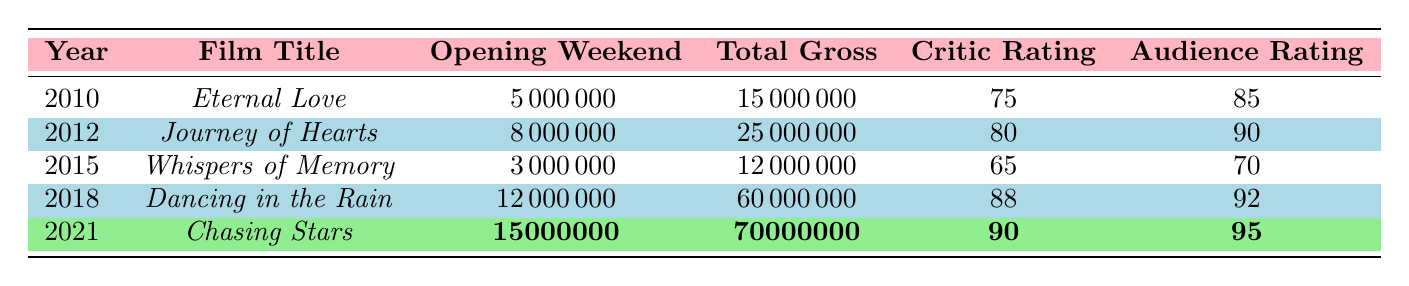What film had the highest opening weekend gross? By examining the "Opening Weekend" column, we see that "Chasing Stars" has the highest gross, which is 15,000,000.
Answer: Chasing Stars What is the total gross of "Dancing in the Rain"? Referring to the table, "Dancing in the Rain" has a total gross of 60,000,000.
Answer: 60,000,000 What was the average critic rating of Prema Kiran's films listed here? Adding the critic ratings: 75 + 80 + 65 + 88 + 90 = 398. There are 5 films, so the average is 398/5 = 79.6.
Answer: 79.6 Did "Whispers of Memory" have a higher audience rating than critic rating? "Whispers of Memory" has an audience rating of 70 and a critic rating of 65. Since 70 is greater than 65, the statement is true.
Answer: Yes What is the total gross difference between "Journey of Hearts" and "Whispers of Memory"? The total gross of "Journey of Hearts" is 25,000,000, and for "Whispers of Memory" it is 12,000,000. The difference is 25,000,000 - 12,000,000 = 13,000,000.
Answer: 13,000,000 Which film received the highest audience rating? "Chasing Stars" received the highest audience rating of 95 when reviewing the audience rating column of the table.
Answer: Chasing Stars What year had the lowest opening weekend gross? Checking the "Opening Weekend" column, the lowest value is 3,000,000 for "Whispers of Memory," which was released in 2015.
Answer: 2015 How many films have a total gross greater than 20,000,000? Analyzing the "Total Gross" column, "Journey of Hearts," "Dancing in the Rain," and "Chasing Stars" have totals greater than 20,000,000, totaling 3 films.
Answer: 3 